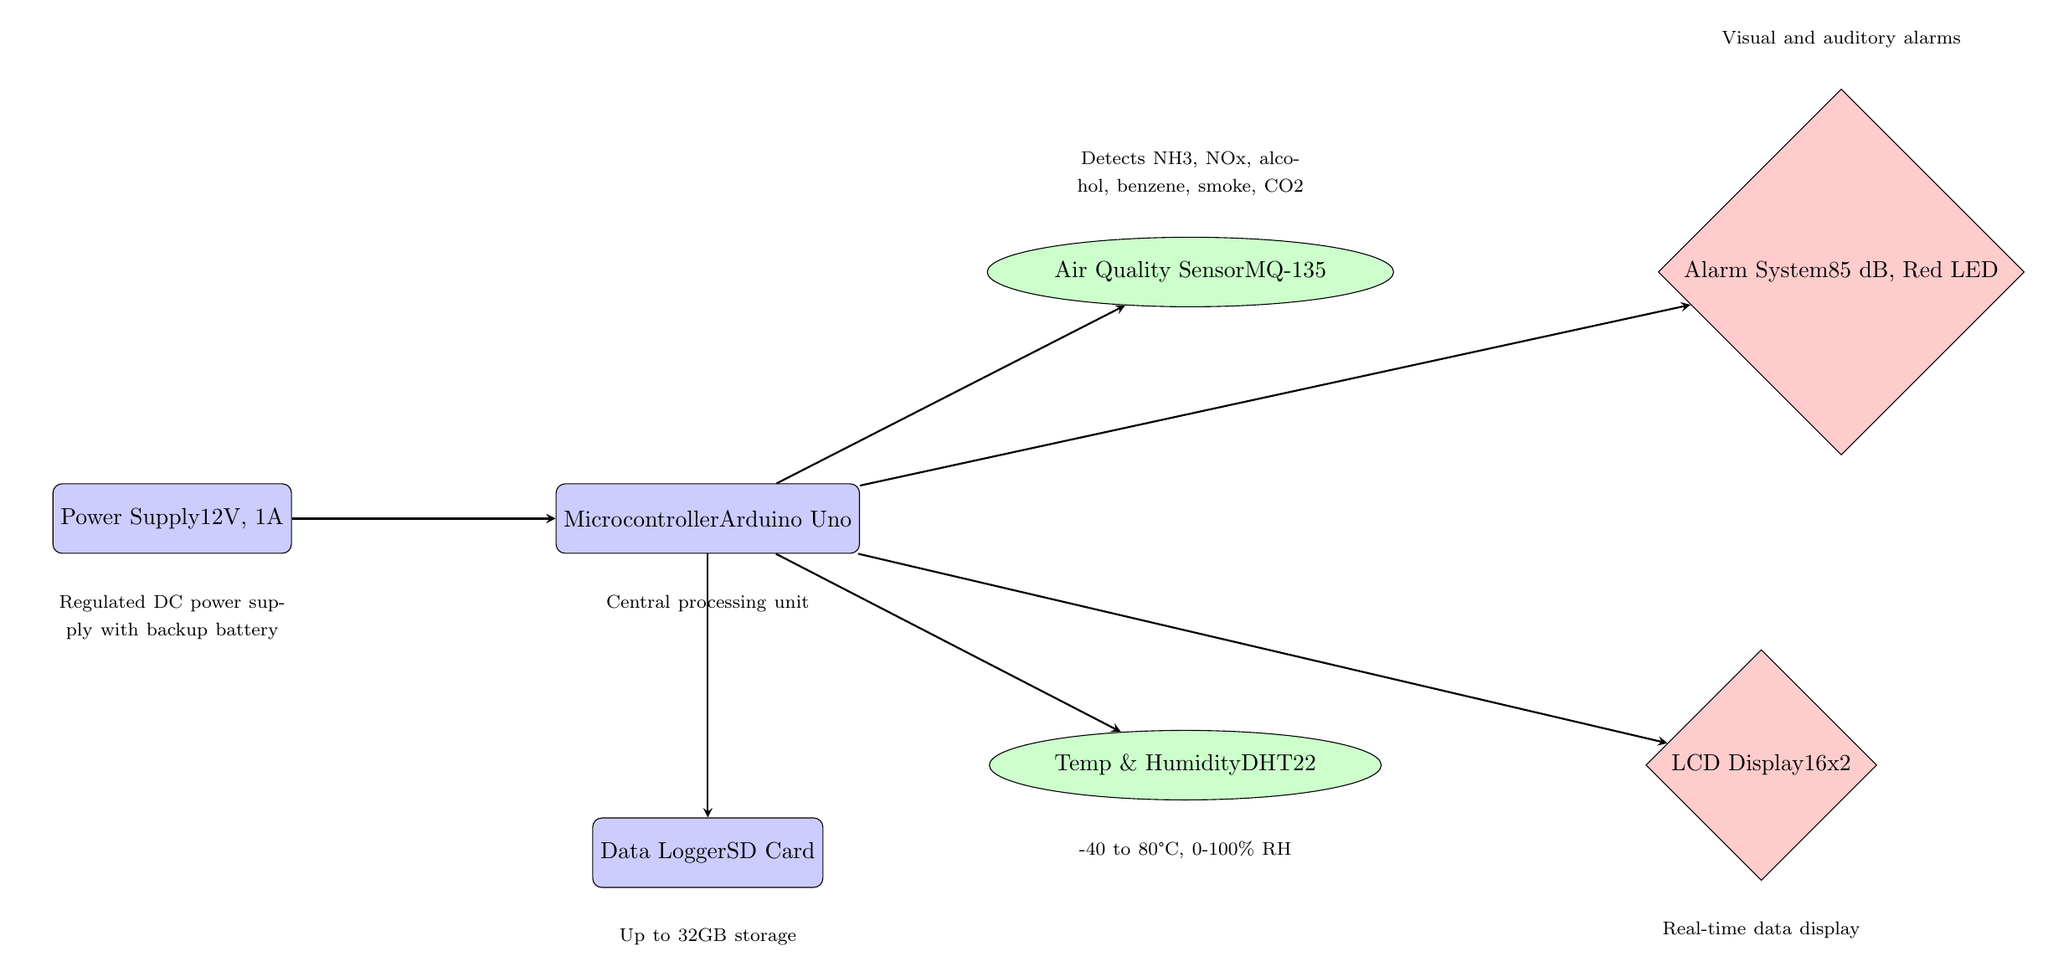What is the power supply voltage in the circuit? The diagram shows a node labeled "Power Supply" with the specification of "12V, 1A." Therefore, the voltage in the circuit is indicated directly in this label.
Answer: 12V How many sensors are present in the diagram? The diagram features two nodes marked as sensors: "Air Quality Sensor" and "Temp & Humidity." Counting these two nodes gives the total number of sensors.
Answer: 2 What component is responsible for communication with the alarm system? The diagram shows an arrow pointing from the "Microcontroller" to the "Alarm System," indicating that the microcontroller is the component controlling or communicating with the alarm system.
Answer: Microcontroller Which sensor detects temperature and humidity? According to the diagram, the node labeled "Temp & Humidity" is specifically for this function, as identified in its designation.
Answer: Temp & Humidity What is the function of the data logger in the circuit? The "Data Logger" is specified in the diagram as having "SD Card," indicating its role in storing data collected from the sensors. This assists in retaining measurements for analysis or future reference.
Answer: Up to 32GB storage What type of display is used for real-time data? The diagram includes a node labeled "LCD Display," defined as "16x2," which specifies the type and size of display used for real-time data representation.
Answer: LCD Display What type of sensor is the MQ-135? The diagram labels the "Air Quality Sensor" specifically as "MQ-135," indicating its designation as a type of air quality sensor suited for detecting multiple gaseous compounds.
Answer: MQ-135 What is the main processing unit in the circuit? The diagram clearly identifies the "Microcontroller" as the central processing unit of the circuit, which manages all logic and communication between components.
Answer: Microcontroller Describe the voltage and current rating of the power supply. The power supply node in the diagram is labeled as "12V, 1A," indicating that it provides a voltage of 12 volts and a current rating of 1 ampere.
Answer: 12V, 1A 